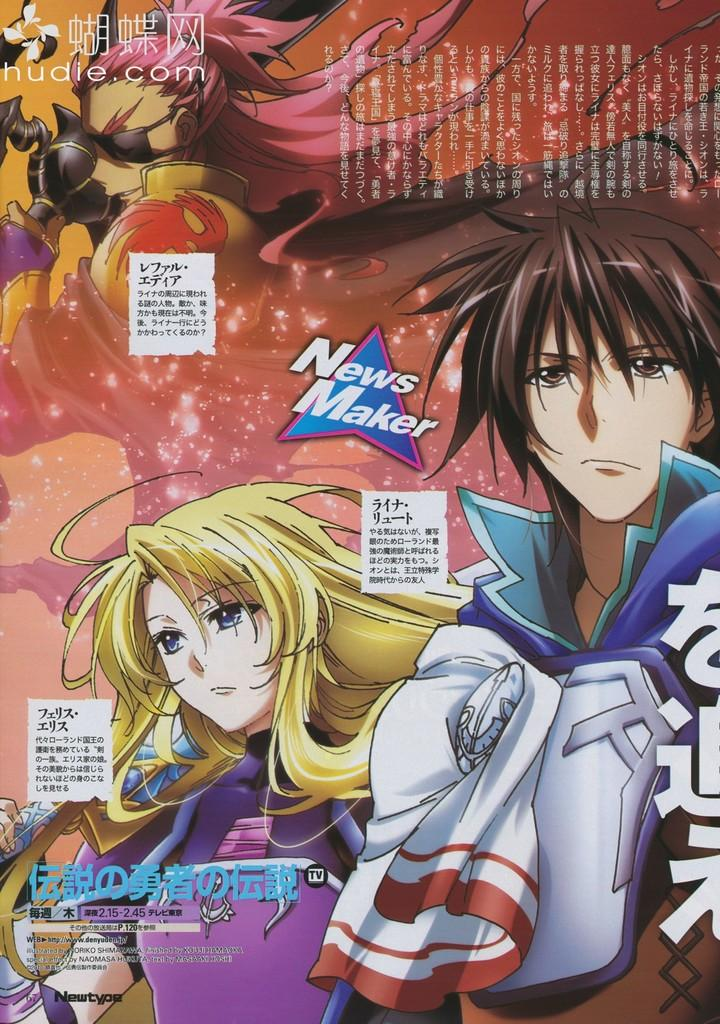What type of poster is depicted in the image? The poster is animated. What characters can be seen on the animated poster? There are animated people on the poster. Is there any text present on the poster? Yes, there is text written on the poster. What type of egg is featured in the image? There is no egg present in the image; it features an animated poster with people and text. 